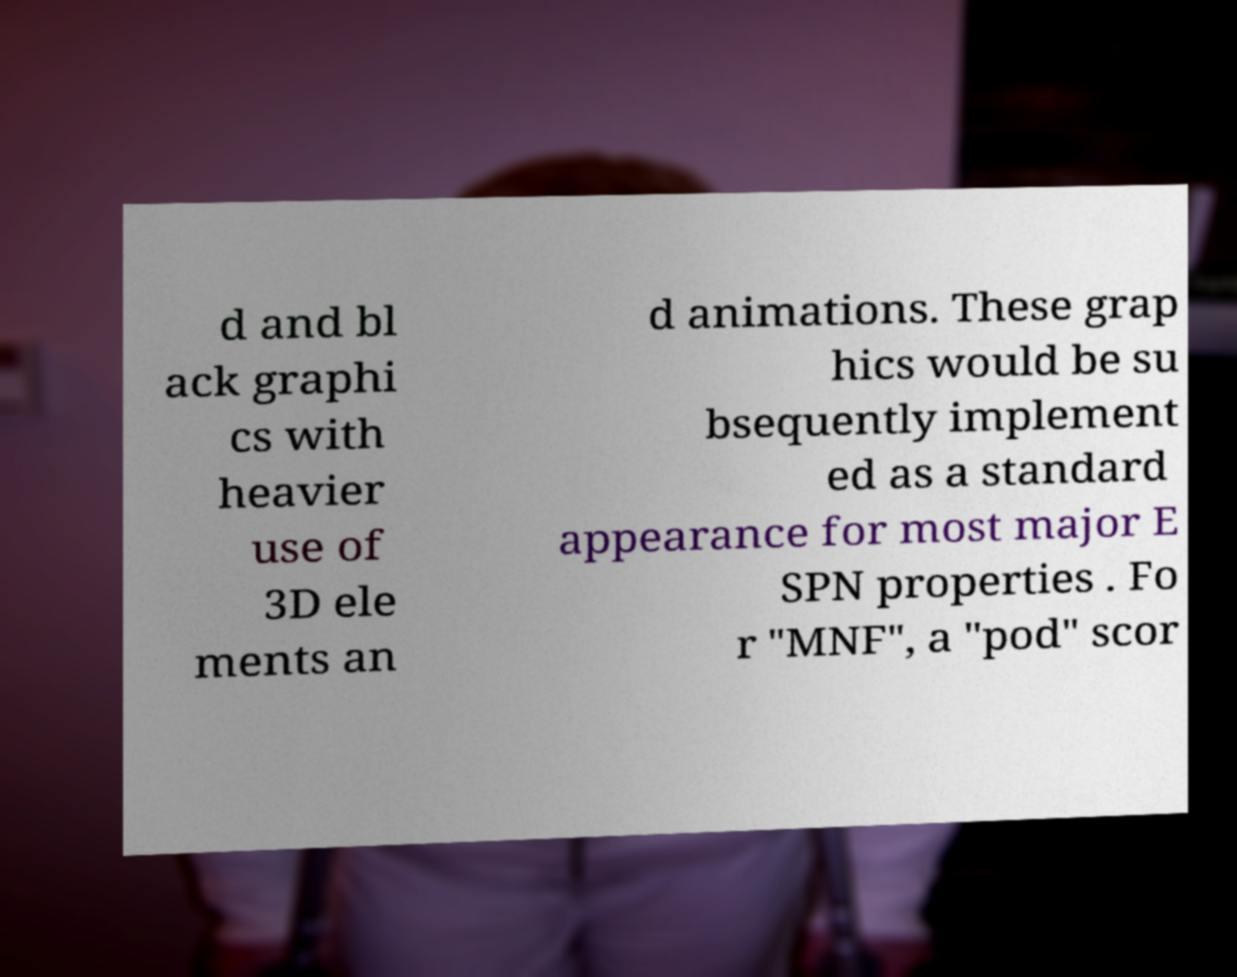There's text embedded in this image that I need extracted. Can you transcribe it verbatim? d and bl ack graphi cs with heavier use of 3D ele ments an d animations. These grap hics would be su bsequently implement ed as a standard appearance for most major E SPN properties . Fo r "MNF", a "pod" scor 